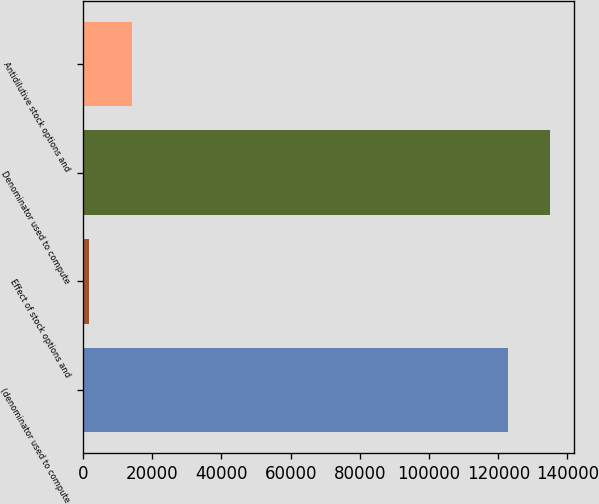Convert chart to OTSL. <chart><loc_0><loc_0><loc_500><loc_500><bar_chart><fcel>(denominator used to compute<fcel>Effect of stock options and<fcel>Denominator used to compute<fcel>Antidilutive stock options and<nl><fcel>122772<fcel>1762<fcel>135049<fcel>14039.2<nl></chart> 